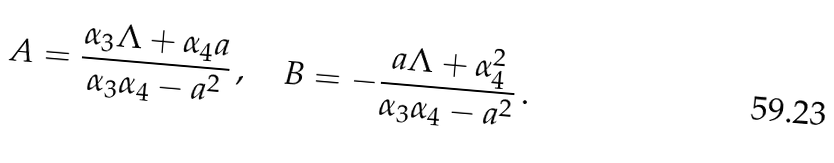<formula> <loc_0><loc_0><loc_500><loc_500>A = \frac { \alpha _ { 3 } \Lambda + \alpha _ { 4 } a } { \alpha _ { 3 } \alpha _ { 4 } - a ^ { 2 } } \, , \quad B = - \frac { a \Lambda + \alpha _ { 4 } ^ { 2 } } { \alpha _ { 3 } \alpha _ { 4 } - a ^ { 2 } } \, .</formula> 